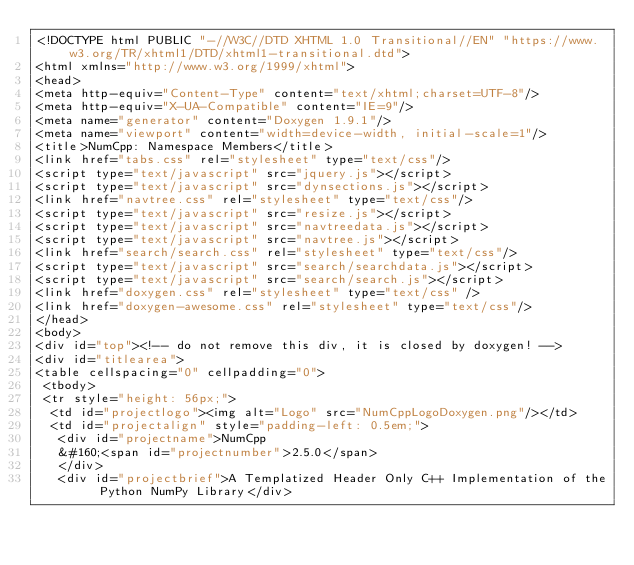Convert code to text. <code><loc_0><loc_0><loc_500><loc_500><_HTML_><!DOCTYPE html PUBLIC "-//W3C//DTD XHTML 1.0 Transitional//EN" "https://www.w3.org/TR/xhtml1/DTD/xhtml1-transitional.dtd">
<html xmlns="http://www.w3.org/1999/xhtml">
<head>
<meta http-equiv="Content-Type" content="text/xhtml;charset=UTF-8"/>
<meta http-equiv="X-UA-Compatible" content="IE=9"/>
<meta name="generator" content="Doxygen 1.9.1"/>
<meta name="viewport" content="width=device-width, initial-scale=1"/>
<title>NumCpp: Namespace Members</title>
<link href="tabs.css" rel="stylesheet" type="text/css"/>
<script type="text/javascript" src="jquery.js"></script>
<script type="text/javascript" src="dynsections.js"></script>
<link href="navtree.css" rel="stylesheet" type="text/css"/>
<script type="text/javascript" src="resize.js"></script>
<script type="text/javascript" src="navtreedata.js"></script>
<script type="text/javascript" src="navtree.js"></script>
<link href="search/search.css" rel="stylesheet" type="text/css"/>
<script type="text/javascript" src="search/searchdata.js"></script>
<script type="text/javascript" src="search/search.js"></script>
<link href="doxygen.css" rel="stylesheet" type="text/css" />
<link href="doxygen-awesome.css" rel="stylesheet" type="text/css"/>
</head>
<body>
<div id="top"><!-- do not remove this div, it is closed by doxygen! -->
<div id="titlearea">
<table cellspacing="0" cellpadding="0">
 <tbody>
 <tr style="height: 56px;">
  <td id="projectlogo"><img alt="Logo" src="NumCppLogoDoxygen.png"/></td>
  <td id="projectalign" style="padding-left: 0.5em;">
   <div id="projectname">NumCpp
   &#160;<span id="projectnumber">2.5.0</span>
   </div>
   <div id="projectbrief">A Templatized Header Only C++ Implementation of the Python NumPy Library</div></code> 